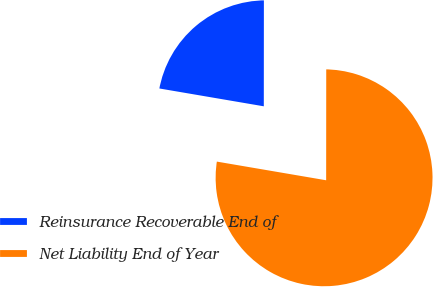Convert chart to OTSL. <chart><loc_0><loc_0><loc_500><loc_500><pie_chart><fcel>Reinsurance Recoverable End of<fcel>Net Liability End of Year<nl><fcel>22.32%<fcel>77.68%<nl></chart> 